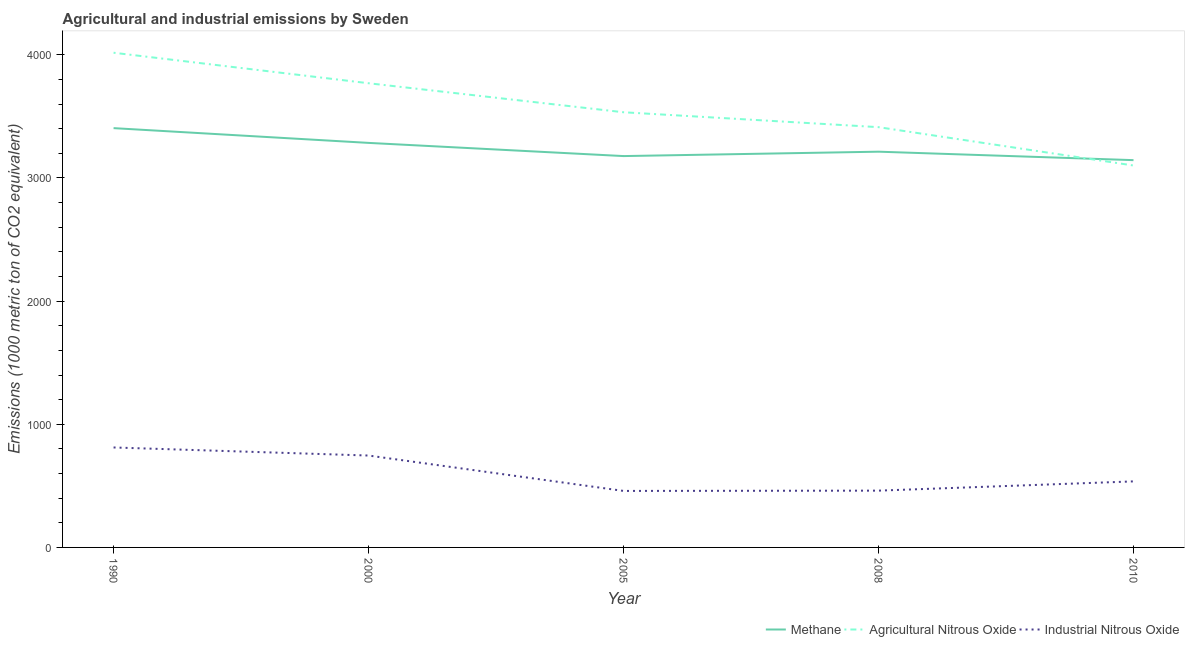What is the amount of methane emissions in 2005?
Offer a very short reply. 3177.6. Across all years, what is the maximum amount of methane emissions?
Offer a terse response. 3404.5. Across all years, what is the minimum amount of agricultural nitrous oxide emissions?
Your answer should be very brief. 3101. In which year was the amount of agricultural nitrous oxide emissions minimum?
Your response must be concise. 2010. What is the total amount of methane emissions in the graph?
Make the answer very short. 1.62e+04. What is the difference between the amount of methane emissions in 2000 and that in 2005?
Your answer should be compact. 107.1. What is the difference between the amount of industrial nitrous oxide emissions in 2008 and the amount of methane emissions in 2000?
Make the answer very short. -2823.6. What is the average amount of agricultural nitrous oxide emissions per year?
Your response must be concise. 3566.5. In the year 1990, what is the difference between the amount of agricultural nitrous oxide emissions and amount of methane emissions?
Your response must be concise. 612.2. In how many years, is the amount of industrial nitrous oxide emissions greater than 2600 metric ton?
Provide a succinct answer. 0. What is the ratio of the amount of methane emissions in 1990 to that in 2010?
Keep it short and to the point. 1.08. Is the amount of methane emissions in 1990 less than that in 2010?
Make the answer very short. No. Is the difference between the amount of agricultural nitrous oxide emissions in 1990 and 2005 greater than the difference between the amount of methane emissions in 1990 and 2005?
Your answer should be very brief. Yes. What is the difference between the highest and the second highest amount of methane emissions?
Make the answer very short. 119.8. What is the difference between the highest and the lowest amount of industrial nitrous oxide emissions?
Keep it short and to the point. 352.8. Is the sum of the amount of agricultural nitrous oxide emissions in 2000 and 2005 greater than the maximum amount of industrial nitrous oxide emissions across all years?
Your response must be concise. Yes. Is it the case that in every year, the sum of the amount of methane emissions and amount of agricultural nitrous oxide emissions is greater than the amount of industrial nitrous oxide emissions?
Provide a short and direct response. Yes. Is the amount of methane emissions strictly less than the amount of agricultural nitrous oxide emissions over the years?
Offer a terse response. No. What is the difference between two consecutive major ticks on the Y-axis?
Make the answer very short. 1000. Are the values on the major ticks of Y-axis written in scientific E-notation?
Your answer should be very brief. No. Does the graph contain grids?
Provide a short and direct response. No. Where does the legend appear in the graph?
Your answer should be very brief. Bottom right. How many legend labels are there?
Make the answer very short. 3. How are the legend labels stacked?
Your answer should be very brief. Horizontal. What is the title of the graph?
Offer a very short reply. Agricultural and industrial emissions by Sweden. Does "Social insurance" appear as one of the legend labels in the graph?
Your answer should be compact. No. What is the label or title of the Y-axis?
Provide a short and direct response. Emissions (1000 metric ton of CO2 equivalent). What is the Emissions (1000 metric ton of CO2 equivalent) of Methane in 1990?
Offer a terse response. 3404.5. What is the Emissions (1000 metric ton of CO2 equivalent) in Agricultural Nitrous Oxide in 1990?
Your answer should be compact. 4016.7. What is the Emissions (1000 metric ton of CO2 equivalent) in Industrial Nitrous Oxide in 1990?
Your answer should be compact. 811.6. What is the Emissions (1000 metric ton of CO2 equivalent) in Methane in 2000?
Offer a very short reply. 3284.7. What is the Emissions (1000 metric ton of CO2 equivalent) in Agricultural Nitrous Oxide in 2000?
Make the answer very short. 3769. What is the Emissions (1000 metric ton of CO2 equivalent) of Industrial Nitrous Oxide in 2000?
Provide a short and direct response. 746.1. What is the Emissions (1000 metric ton of CO2 equivalent) of Methane in 2005?
Your answer should be very brief. 3177.6. What is the Emissions (1000 metric ton of CO2 equivalent) of Agricultural Nitrous Oxide in 2005?
Your answer should be very brief. 3533.4. What is the Emissions (1000 metric ton of CO2 equivalent) in Industrial Nitrous Oxide in 2005?
Your answer should be very brief. 458.8. What is the Emissions (1000 metric ton of CO2 equivalent) in Methane in 2008?
Offer a very short reply. 3213.3. What is the Emissions (1000 metric ton of CO2 equivalent) of Agricultural Nitrous Oxide in 2008?
Keep it short and to the point. 3412.4. What is the Emissions (1000 metric ton of CO2 equivalent) of Industrial Nitrous Oxide in 2008?
Your response must be concise. 461.1. What is the Emissions (1000 metric ton of CO2 equivalent) in Methane in 2010?
Keep it short and to the point. 3144.6. What is the Emissions (1000 metric ton of CO2 equivalent) in Agricultural Nitrous Oxide in 2010?
Ensure brevity in your answer.  3101. What is the Emissions (1000 metric ton of CO2 equivalent) in Industrial Nitrous Oxide in 2010?
Your answer should be compact. 536.2. Across all years, what is the maximum Emissions (1000 metric ton of CO2 equivalent) of Methane?
Your answer should be very brief. 3404.5. Across all years, what is the maximum Emissions (1000 metric ton of CO2 equivalent) of Agricultural Nitrous Oxide?
Provide a succinct answer. 4016.7. Across all years, what is the maximum Emissions (1000 metric ton of CO2 equivalent) of Industrial Nitrous Oxide?
Keep it short and to the point. 811.6. Across all years, what is the minimum Emissions (1000 metric ton of CO2 equivalent) in Methane?
Provide a short and direct response. 3144.6. Across all years, what is the minimum Emissions (1000 metric ton of CO2 equivalent) in Agricultural Nitrous Oxide?
Give a very brief answer. 3101. Across all years, what is the minimum Emissions (1000 metric ton of CO2 equivalent) in Industrial Nitrous Oxide?
Your answer should be compact. 458.8. What is the total Emissions (1000 metric ton of CO2 equivalent) in Methane in the graph?
Offer a terse response. 1.62e+04. What is the total Emissions (1000 metric ton of CO2 equivalent) of Agricultural Nitrous Oxide in the graph?
Provide a succinct answer. 1.78e+04. What is the total Emissions (1000 metric ton of CO2 equivalent) in Industrial Nitrous Oxide in the graph?
Ensure brevity in your answer.  3013.8. What is the difference between the Emissions (1000 metric ton of CO2 equivalent) of Methane in 1990 and that in 2000?
Your answer should be very brief. 119.8. What is the difference between the Emissions (1000 metric ton of CO2 equivalent) in Agricultural Nitrous Oxide in 1990 and that in 2000?
Keep it short and to the point. 247.7. What is the difference between the Emissions (1000 metric ton of CO2 equivalent) in Industrial Nitrous Oxide in 1990 and that in 2000?
Ensure brevity in your answer.  65.5. What is the difference between the Emissions (1000 metric ton of CO2 equivalent) of Methane in 1990 and that in 2005?
Your answer should be very brief. 226.9. What is the difference between the Emissions (1000 metric ton of CO2 equivalent) of Agricultural Nitrous Oxide in 1990 and that in 2005?
Provide a succinct answer. 483.3. What is the difference between the Emissions (1000 metric ton of CO2 equivalent) in Industrial Nitrous Oxide in 1990 and that in 2005?
Your answer should be compact. 352.8. What is the difference between the Emissions (1000 metric ton of CO2 equivalent) of Methane in 1990 and that in 2008?
Ensure brevity in your answer.  191.2. What is the difference between the Emissions (1000 metric ton of CO2 equivalent) of Agricultural Nitrous Oxide in 1990 and that in 2008?
Ensure brevity in your answer.  604.3. What is the difference between the Emissions (1000 metric ton of CO2 equivalent) of Industrial Nitrous Oxide in 1990 and that in 2008?
Your answer should be very brief. 350.5. What is the difference between the Emissions (1000 metric ton of CO2 equivalent) of Methane in 1990 and that in 2010?
Give a very brief answer. 259.9. What is the difference between the Emissions (1000 metric ton of CO2 equivalent) of Agricultural Nitrous Oxide in 1990 and that in 2010?
Keep it short and to the point. 915.7. What is the difference between the Emissions (1000 metric ton of CO2 equivalent) in Industrial Nitrous Oxide in 1990 and that in 2010?
Your answer should be very brief. 275.4. What is the difference between the Emissions (1000 metric ton of CO2 equivalent) of Methane in 2000 and that in 2005?
Ensure brevity in your answer.  107.1. What is the difference between the Emissions (1000 metric ton of CO2 equivalent) in Agricultural Nitrous Oxide in 2000 and that in 2005?
Your answer should be compact. 235.6. What is the difference between the Emissions (1000 metric ton of CO2 equivalent) in Industrial Nitrous Oxide in 2000 and that in 2005?
Ensure brevity in your answer.  287.3. What is the difference between the Emissions (1000 metric ton of CO2 equivalent) in Methane in 2000 and that in 2008?
Your answer should be very brief. 71.4. What is the difference between the Emissions (1000 metric ton of CO2 equivalent) of Agricultural Nitrous Oxide in 2000 and that in 2008?
Keep it short and to the point. 356.6. What is the difference between the Emissions (1000 metric ton of CO2 equivalent) in Industrial Nitrous Oxide in 2000 and that in 2008?
Keep it short and to the point. 285. What is the difference between the Emissions (1000 metric ton of CO2 equivalent) of Methane in 2000 and that in 2010?
Your answer should be compact. 140.1. What is the difference between the Emissions (1000 metric ton of CO2 equivalent) of Agricultural Nitrous Oxide in 2000 and that in 2010?
Keep it short and to the point. 668. What is the difference between the Emissions (1000 metric ton of CO2 equivalent) of Industrial Nitrous Oxide in 2000 and that in 2010?
Keep it short and to the point. 209.9. What is the difference between the Emissions (1000 metric ton of CO2 equivalent) in Methane in 2005 and that in 2008?
Your answer should be compact. -35.7. What is the difference between the Emissions (1000 metric ton of CO2 equivalent) of Agricultural Nitrous Oxide in 2005 and that in 2008?
Provide a short and direct response. 121. What is the difference between the Emissions (1000 metric ton of CO2 equivalent) in Methane in 2005 and that in 2010?
Offer a terse response. 33. What is the difference between the Emissions (1000 metric ton of CO2 equivalent) of Agricultural Nitrous Oxide in 2005 and that in 2010?
Offer a terse response. 432.4. What is the difference between the Emissions (1000 metric ton of CO2 equivalent) of Industrial Nitrous Oxide in 2005 and that in 2010?
Provide a succinct answer. -77.4. What is the difference between the Emissions (1000 metric ton of CO2 equivalent) in Methane in 2008 and that in 2010?
Make the answer very short. 68.7. What is the difference between the Emissions (1000 metric ton of CO2 equivalent) in Agricultural Nitrous Oxide in 2008 and that in 2010?
Your answer should be very brief. 311.4. What is the difference between the Emissions (1000 metric ton of CO2 equivalent) of Industrial Nitrous Oxide in 2008 and that in 2010?
Make the answer very short. -75.1. What is the difference between the Emissions (1000 metric ton of CO2 equivalent) of Methane in 1990 and the Emissions (1000 metric ton of CO2 equivalent) of Agricultural Nitrous Oxide in 2000?
Give a very brief answer. -364.5. What is the difference between the Emissions (1000 metric ton of CO2 equivalent) of Methane in 1990 and the Emissions (1000 metric ton of CO2 equivalent) of Industrial Nitrous Oxide in 2000?
Offer a terse response. 2658.4. What is the difference between the Emissions (1000 metric ton of CO2 equivalent) in Agricultural Nitrous Oxide in 1990 and the Emissions (1000 metric ton of CO2 equivalent) in Industrial Nitrous Oxide in 2000?
Offer a very short reply. 3270.6. What is the difference between the Emissions (1000 metric ton of CO2 equivalent) in Methane in 1990 and the Emissions (1000 metric ton of CO2 equivalent) in Agricultural Nitrous Oxide in 2005?
Keep it short and to the point. -128.9. What is the difference between the Emissions (1000 metric ton of CO2 equivalent) in Methane in 1990 and the Emissions (1000 metric ton of CO2 equivalent) in Industrial Nitrous Oxide in 2005?
Your answer should be very brief. 2945.7. What is the difference between the Emissions (1000 metric ton of CO2 equivalent) in Agricultural Nitrous Oxide in 1990 and the Emissions (1000 metric ton of CO2 equivalent) in Industrial Nitrous Oxide in 2005?
Give a very brief answer. 3557.9. What is the difference between the Emissions (1000 metric ton of CO2 equivalent) in Methane in 1990 and the Emissions (1000 metric ton of CO2 equivalent) in Agricultural Nitrous Oxide in 2008?
Your response must be concise. -7.9. What is the difference between the Emissions (1000 metric ton of CO2 equivalent) of Methane in 1990 and the Emissions (1000 metric ton of CO2 equivalent) of Industrial Nitrous Oxide in 2008?
Your answer should be very brief. 2943.4. What is the difference between the Emissions (1000 metric ton of CO2 equivalent) of Agricultural Nitrous Oxide in 1990 and the Emissions (1000 metric ton of CO2 equivalent) of Industrial Nitrous Oxide in 2008?
Your answer should be very brief. 3555.6. What is the difference between the Emissions (1000 metric ton of CO2 equivalent) of Methane in 1990 and the Emissions (1000 metric ton of CO2 equivalent) of Agricultural Nitrous Oxide in 2010?
Provide a succinct answer. 303.5. What is the difference between the Emissions (1000 metric ton of CO2 equivalent) of Methane in 1990 and the Emissions (1000 metric ton of CO2 equivalent) of Industrial Nitrous Oxide in 2010?
Make the answer very short. 2868.3. What is the difference between the Emissions (1000 metric ton of CO2 equivalent) in Agricultural Nitrous Oxide in 1990 and the Emissions (1000 metric ton of CO2 equivalent) in Industrial Nitrous Oxide in 2010?
Provide a succinct answer. 3480.5. What is the difference between the Emissions (1000 metric ton of CO2 equivalent) of Methane in 2000 and the Emissions (1000 metric ton of CO2 equivalent) of Agricultural Nitrous Oxide in 2005?
Your response must be concise. -248.7. What is the difference between the Emissions (1000 metric ton of CO2 equivalent) in Methane in 2000 and the Emissions (1000 metric ton of CO2 equivalent) in Industrial Nitrous Oxide in 2005?
Your answer should be very brief. 2825.9. What is the difference between the Emissions (1000 metric ton of CO2 equivalent) of Agricultural Nitrous Oxide in 2000 and the Emissions (1000 metric ton of CO2 equivalent) of Industrial Nitrous Oxide in 2005?
Your response must be concise. 3310.2. What is the difference between the Emissions (1000 metric ton of CO2 equivalent) of Methane in 2000 and the Emissions (1000 metric ton of CO2 equivalent) of Agricultural Nitrous Oxide in 2008?
Keep it short and to the point. -127.7. What is the difference between the Emissions (1000 metric ton of CO2 equivalent) in Methane in 2000 and the Emissions (1000 metric ton of CO2 equivalent) in Industrial Nitrous Oxide in 2008?
Keep it short and to the point. 2823.6. What is the difference between the Emissions (1000 metric ton of CO2 equivalent) of Agricultural Nitrous Oxide in 2000 and the Emissions (1000 metric ton of CO2 equivalent) of Industrial Nitrous Oxide in 2008?
Ensure brevity in your answer.  3307.9. What is the difference between the Emissions (1000 metric ton of CO2 equivalent) of Methane in 2000 and the Emissions (1000 metric ton of CO2 equivalent) of Agricultural Nitrous Oxide in 2010?
Offer a very short reply. 183.7. What is the difference between the Emissions (1000 metric ton of CO2 equivalent) of Methane in 2000 and the Emissions (1000 metric ton of CO2 equivalent) of Industrial Nitrous Oxide in 2010?
Keep it short and to the point. 2748.5. What is the difference between the Emissions (1000 metric ton of CO2 equivalent) of Agricultural Nitrous Oxide in 2000 and the Emissions (1000 metric ton of CO2 equivalent) of Industrial Nitrous Oxide in 2010?
Your answer should be very brief. 3232.8. What is the difference between the Emissions (1000 metric ton of CO2 equivalent) of Methane in 2005 and the Emissions (1000 metric ton of CO2 equivalent) of Agricultural Nitrous Oxide in 2008?
Offer a terse response. -234.8. What is the difference between the Emissions (1000 metric ton of CO2 equivalent) in Methane in 2005 and the Emissions (1000 metric ton of CO2 equivalent) in Industrial Nitrous Oxide in 2008?
Provide a short and direct response. 2716.5. What is the difference between the Emissions (1000 metric ton of CO2 equivalent) of Agricultural Nitrous Oxide in 2005 and the Emissions (1000 metric ton of CO2 equivalent) of Industrial Nitrous Oxide in 2008?
Make the answer very short. 3072.3. What is the difference between the Emissions (1000 metric ton of CO2 equivalent) of Methane in 2005 and the Emissions (1000 metric ton of CO2 equivalent) of Agricultural Nitrous Oxide in 2010?
Ensure brevity in your answer.  76.6. What is the difference between the Emissions (1000 metric ton of CO2 equivalent) in Methane in 2005 and the Emissions (1000 metric ton of CO2 equivalent) in Industrial Nitrous Oxide in 2010?
Make the answer very short. 2641.4. What is the difference between the Emissions (1000 metric ton of CO2 equivalent) in Agricultural Nitrous Oxide in 2005 and the Emissions (1000 metric ton of CO2 equivalent) in Industrial Nitrous Oxide in 2010?
Give a very brief answer. 2997.2. What is the difference between the Emissions (1000 metric ton of CO2 equivalent) in Methane in 2008 and the Emissions (1000 metric ton of CO2 equivalent) in Agricultural Nitrous Oxide in 2010?
Give a very brief answer. 112.3. What is the difference between the Emissions (1000 metric ton of CO2 equivalent) of Methane in 2008 and the Emissions (1000 metric ton of CO2 equivalent) of Industrial Nitrous Oxide in 2010?
Provide a short and direct response. 2677.1. What is the difference between the Emissions (1000 metric ton of CO2 equivalent) of Agricultural Nitrous Oxide in 2008 and the Emissions (1000 metric ton of CO2 equivalent) of Industrial Nitrous Oxide in 2010?
Provide a succinct answer. 2876.2. What is the average Emissions (1000 metric ton of CO2 equivalent) in Methane per year?
Offer a very short reply. 3244.94. What is the average Emissions (1000 metric ton of CO2 equivalent) in Agricultural Nitrous Oxide per year?
Your answer should be compact. 3566.5. What is the average Emissions (1000 metric ton of CO2 equivalent) of Industrial Nitrous Oxide per year?
Make the answer very short. 602.76. In the year 1990, what is the difference between the Emissions (1000 metric ton of CO2 equivalent) in Methane and Emissions (1000 metric ton of CO2 equivalent) in Agricultural Nitrous Oxide?
Ensure brevity in your answer.  -612.2. In the year 1990, what is the difference between the Emissions (1000 metric ton of CO2 equivalent) of Methane and Emissions (1000 metric ton of CO2 equivalent) of Industrial Nitrous Oxide?
Offer a terse response. 2592.9. In the year 1990, what is the difference between the Emissions (1000 metric ton of CO2 equivalent) of Agricultural Nitrous Oxide and Emissions (1000 metric ton of CO2 equivalent) of Industrial Nitrous Oxide?
Your response must be concise. 3205.1. In the year 2000, what is the difference between the Emissions (1000 metric ton of CO2 equivalent) of Methane and Emissions (1000 metric ton of CO2 equivalent) of Agricultural Nitrous Oxide?
Ensure brevity in your answer.  -484.3. In the year 2000, what is the difference between the Emissions (1000 metric ton of CO2 equivalent) of Methane and Emissions (1000 metric ton of CO2 equivalent) of Industrial Nitrous Oxide?
Your answer should be compact. 2538.6. In the year 2000, what is the difference between the Emissions (1000 metric ton of CO2 equivalent) in Agricultural Nitrous Oxide and Emissions (1000 metric ton of CO2 equivalent) in Industrial Nitrous Oxide?
Offer a terse response. 3022.9. In the year 2005, what is the difference between the Emissions (1000 metric ton of CO2 equivalent) of Methane and Emissions (1000 metric ton of CO2 equivalent) of Agricultural Nitrous Oxide?
Make the answer very short. -355.8. In the year 2005, what is the difference between the Emissions (1000 metric ton of CO2 equivalent) in Methane and Emissions (1000 metric ton of CO2 equivalent) in Industrial Nitrous Oxide?
Give a very brief answer. 2718.8. In the year 2005, what is the difference between the Emissions (1000 metric ton of CO2 equivalent) of Agricultural Nitrous Oxide and Emissions (1000 metric ton of CO2 equivalent) of Industrial Nitrous Oxide?
Your answer should be compact. 3074.6. In the year 2008, what is the difference between the Emissions (1000 metric ton of CO2 equivalent) of Methane and Emissions (1000 metric ton of CO2 equivalent) of Agricultural Nitrous Oxide?
Your answer should be compact. -199.1. In the year 2008, what is the difference between the Emissions (1000 metric ton of CO2 equivalent) of Methane and Emissions (1000 metric ton of CO2 equivalent) of Industrial Nitrous Oxide?
Offer a very short reply. 2752.2. In the year 2008, what is the difference between the Emissions (1000 metric ton of CO2 equivalent) in Agricultural Nitrous Oxide and Emissions (1000 metric ton of CO2 equivalent) in Industrial Nitrous Oxide?
Provide a short and direct response. 2951.3. In the year 2010, what is the difference between the Emissions (1000 metric ton of CO2 equivalent) in Methane and Emissions (1000 metric ton of CO2 equivalent) in Agricultural Nitrous Oxide?
Your answer should be very brief. 43.6. In the year 2010, what is the difference between the Emissions (1000 metric ton of CO2 equivalent) of Methane and Emissions (1000 metric ton of CO2 equivalent) of Industrial Nitrous Oxide?
Offer a very short reply. 2608.4. In the year 2010, what is the difference between the Emissions (1000 metric ton of CO2 equivalent) of Agricultural Nitrous Oxide and Emissions (1000 metric ton of CO2 equivalent) of Industrial Nitrous Oxide?
Offer a terse response. 2564.8. What is the ratio of the Emissions (1000 metric ton of CO2 equivalent) in Methane in 1990 to that in 2000?
Your response must be concise. 1.04. What is the ratio of the Emissions (1000 metric ton of CO2 equivalent) in Agricultural Nitrous Oxide in 1990 to that in 2000?
Offer a very short reply. 1.07. What is the ratio of the Emissions (1000 metric ton of CO2 equivalent) of Industrial Nitrous Oxide in 1990 to that in 2000?
Your answer should be compact. 1.09. What is the ratio of the Emissions (1000 metric ton of CO2 equivalent) in Methane in 1990 to that in 2005?
Provide a succinct answer. 1.07. What is the ratio of the Emissions (1000 metric ton of CO2 equivalent) in Agricultural Nitrous Oxide in 1990 to that in 2005?
Make the answer very short. 1.14. What is the ratio of the Emissions (1000 metric ton of CO2 equivalent) of Industrial Nitrous Oxide in 1990 to that in 2005?
Keep it short and to the point. 1.77. What is the ratio of the Emissions (1000 metric ton of CO2 equivalent) in Methane in 1990 to that in 2008?
Keep it short and to the point. 1.06. What is the ratio of the Emissions (1000 metric ton of CO2 equivalent) of Agricultural Nitrous Oxide in 1990 to that in 2008?
Ensure brevity in your answer.  1.18. What is the ratio of the Emissions (1000 metric ton of CO2 equivalent) of Industrial Nitrous Oxide in 1990 to that in 2008?
Offer a very short reply. 1.76. What is the ratio of the Emissions (1000 metric ton of CO2 equivalent) in Methane in 1990 to that in 2010?
Provide a short and direct response. 1.08. What is the ratio of the Emissions (1000 metric ton of CO2 equivalent) in Agricultural Nitrous Oxide in 1990 to that in 2010?
Offer a very short reply. 1.3. What is the ratio of the Emissions (1000 metric ton of CO2 equivalent) of Industrial Nitrous Oxide in 1990 to that in 2010?
Provide a short and direct response. 1.51. What is the ratio of the Emissions (1000 metric ton of CO2 equivalent) of Methane in 2000 to that in 2005?
Offer a very short reply. 1.03. What is the ratio of the Emissions (1000 metric ton of CO2 equivalent) of Agricultural Nitrous Oxide in 2000 to that in 2005?
Your response must be concise. 1.07. What is the ratio of the Emissions (1000 metric ton of CO2 equivalent) in Industrial Nitrous Oxide in 2000 to that in 2005?
Offer a terse response. 1.63. What is the ratio of the Emissions (1000 metric ton of CO2 equivalent) in Methane in 2000 to that in 2008?
Give a very brief answer. 1.02. What is the ratio of the Emissions (1000 metric ton of CO2 equivalent) of Agricultural Nitrous Oxide in 2000 to that in 2008?
Your answer should be very brief. 1.1. What is the ratio of the Emissions (1000 metric ton of CO2 equivalent) in Industrial Nitrous Oxide in 2000 to that in 2008?
Your answer should be very brief. 1.62. What is the ratio of the Emissions (1000 metric ton of CO2 equivalent) of Methane in 2000 to that in 2010?
Make the answer very short. 1.04. What is the ratio of the Emissions (1000 metric ton of CO2 equivalent) of Agricultural Nitrous Oxide in 2000 to that in 2010?
Offer a very short reply. 1.22. What is the ratio of the Emissions (1000 metric ton of CO2 equivalent) of Industrial Nitrous Oxide in 2000 to that in 2010?
Keep it short and to the point. 1.39. What is the ratio of the Emissions (1000 metric ton of CO2 equivalent) of Methane in 2005 to that in 2008?
Offer a terse response. 0.99. What is the ratio of the Emissions (1000 metric ton of CO2 equivalent) of Agricultural Nitrous Oxide in 2005 to that in 2008?
Keep it short and to the point. 1.04. What is the ratio of the Emissions (1000 metric ton of CO2 equivalent) of Methane in 2005 to that in 2010?
Make the answer very short. 1.01. What is the ratio of the Emissions (1000 metric ton of CO2 equivalent) of Agricultural Nitrous Oxide in 2005 to that in 2010?
Offer a very short reply. 1.14. What is the ratio of the Emissions (1000 metric ton of CO2 equivalent) of Industrial Nitrous Oxide in 2005 to that in 2010?
Offer a very short reply. 0.86. What is the ratio of the Emissions (1000 metric ton of CO2 equivalent) of Methane in 2008 to that in 2010?
Provide a short and direct response. 1.02. What is the ratio of the Emissions (1000 metric ton of CO2 equivalent) of Agricultural Nitrous Oxide in 2008 to that in 2010?
Ensure brevity in your answer.  1.1. What is the ratio of the Emissions (1000 metric ton of CO2 equivalent) in Industrial Nitrous Oxide in 2008 to that in 2010?
Offer a very short reply. 0.86. What is the difference between the highest and the second highest Emissions (1000 metric ton of CO2 equivalent) in Methane?
Keep it short and to the point. 119.8. What is the difference between the highest and the second highest Emissions (1000 metric ton of CO2 equivalent) of Agricultural Nitrous Oxide?
Provide a succinct answer. 247.7. What is the difference between the highest and the second highest Emissions (1000 metric ton of CO2 equivalent) in Industrial Nitrous Oxide?
Keep it short and to the point. 65.5. What is the difference between the highest and the lowest Emissions (1000 metric ton of CO2 equivalent) in Methane?
Your answer should be compact. 259.9. What is the difference between the highest and the lowest Emissions (1000 metric ton of CO2 equivalent) in Agricultural Nitrous Oxide?
Your answer should be compact. 915.7. What is the difference between the highest and the lowest Emissions (1000 metric ton of CO2 equivalent) of Industrial Nitrous Oxide?
Offer a terse response. 352.8. 